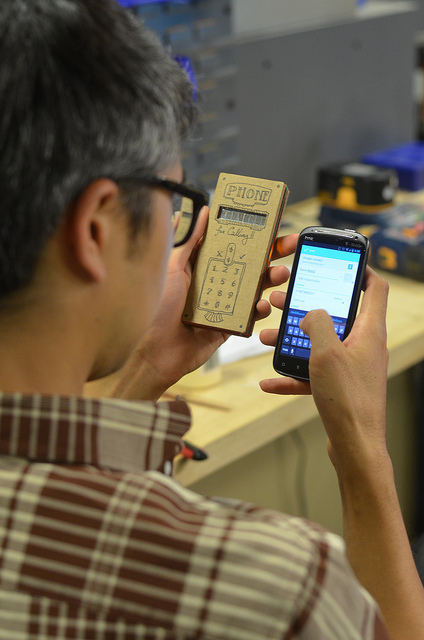Please transcribe the text information in this image. PHONE Cethig 7 2 